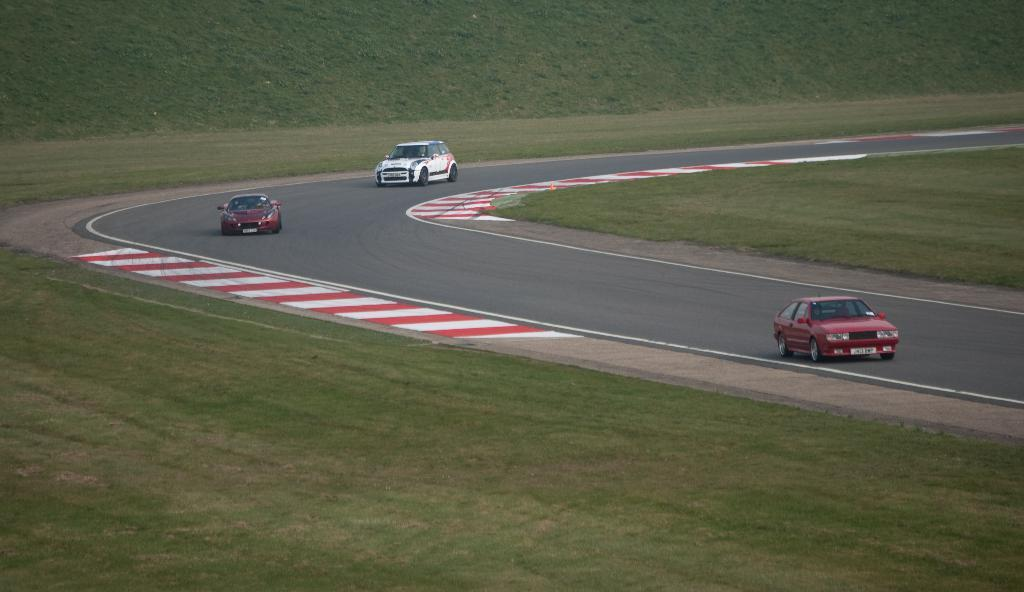How many cars can be seen on the road in the image? There are 3 cars on the road in the image. What type of vegetation is present alongside the road? There is grass on either side of the road. How many women are participating in the event depicted in the image? There is no event or women present in the image; it only shows 3 cars on the road and grass on either side. 